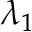<formula> <loc_0><loc_0><loc_500><loc_500>\lambda _ { 1 }</formula> 